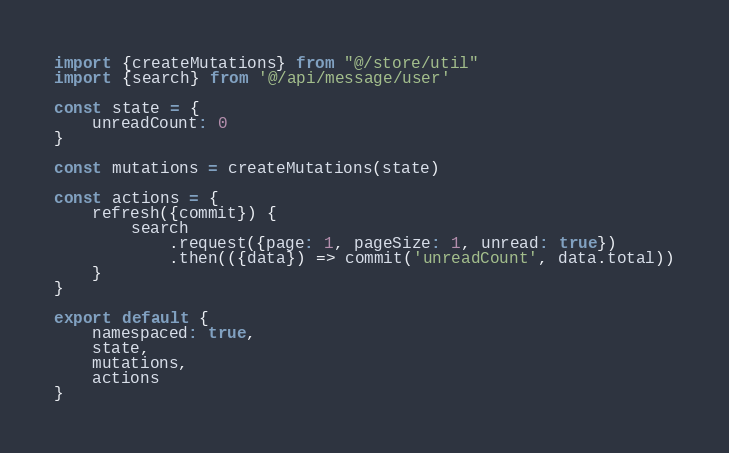Convert code to text. <code><loc_0><loc_0><loc_500><loc_500><_JavaScript_>import {createMutations} from "@/store/util"
import {search} from '@/api/message/user'

const state = {
    unreadCount: 0
}

const mutations = createMutations(state)

const actions = {
    refresh({commit}) {
        search
            .request({page: 1, pageSize: 1, unread: true})
            .then(({data}) => commit('unreadCount', data.total))
    }
}

export default {
    namespaced: true,
    state,
    mutations,
    actions
}
</code> 